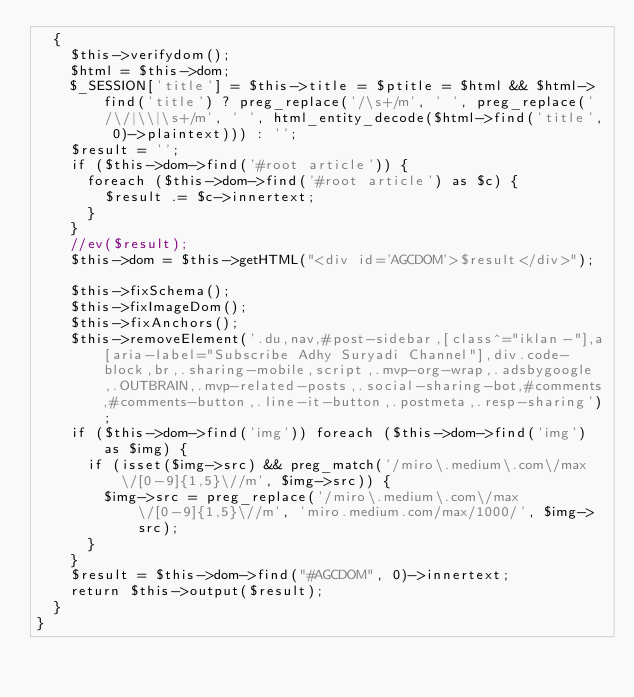<code> <loc_0><loc_0><loc_500><loc_500><_PHP_>  {
    $this->verifydom();
    $html = $this->dom;
    $_SESSION['title'] = $this->title = $ptitle = $html && $html->find('title') ? preg_replace('/\s+/m', ' ', preg_replace('/\/|\\|\s+/m', ' ', html_entity_decode($html->find('title', 0)->plaintext))) : '';
    $result = '';
    if ($this->dom->find('#root article')) {
      foreach ($this->dom->find('#root article') as $c) {
        $result .= $c->innertext;
      }
    }
    //ev($result);
    $this->dom = $this->getHTML("<div id='AGCDOM'>$result</div>");

    $this->fixSchema();
    $this->fixImageDom();
    $this->fixAnchors();
    $this->removeElement('.du,nav,#post-sidebar,[class^="iklan-"],a[aria-label="Subscribe Adhy Suryadi Channel"],div.code-block,br,.sharing-mobile,script,.mvp-org-wrap,.adsbygoogle,.OUTBRAIN,.mvp-related-posts,.social-sharing-bot,#comments,#comments-button,.line-it-button,.postmeta,.resp-sharing');
    if ($this->dom->find('img')) foreach ($this->dom->find('img') as $img) {
      if (isset($img->src) && preg_match('/miro\.medium\.com\/max\/[0-9]{1,5}\//m', $img->src)) {
        $img->src = preg_replace('/miro\.medium\.com\/max\/[0-9]{1,5}\//m', 'miro.medium.com/max/1000/', $img->src);
      }
    }
    $result = $this->dom->find("#AGCDOM", 0)->innertext;
    return $this->output($result);
  }
}
</code> 